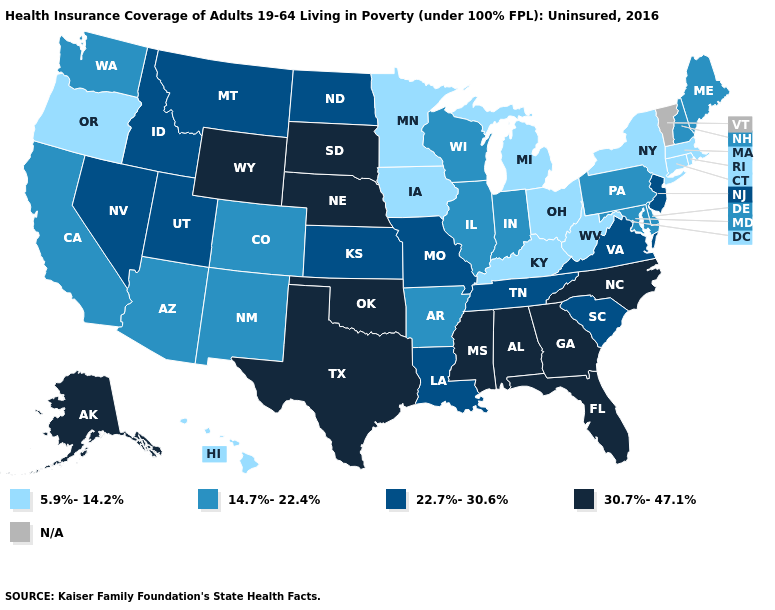What is the value of New Jersey?
Quick response, please. 22.7%-30.6%. Name the states that have a value in the range 22.7%-30.6%?
Short answer required. Idaho, Kansas, Louisiana, Missouri, Montana, Nevada, New Jersey, North Dakota, South Carolina, Tennessee, Utah, Virginia. What is the value of Kansas?
Short answer required. 22.7%-30.6%. Does Wisconsin have the lowest value in the MidWest?
Answer briefly. No. What is the value of South Dakota?
Concise answer only. 30.7%-47.1%. What is the value of Utah?
Give a very brief answer. 22.7%-30.6%. What is the value of Arkansas?
Quick response, please. 14.7%-22.4%. Name the states that have a value in the range 5.9%-14.2%?
Give a very brief answer. Connecticut, Hawaii, Iowa, Kentucky, Massachusetts, Michigan, Minnesota, New York, Ohio, Oregon, Rhode Island, West Virginia. What is the value of New Mexico?
Short answer required. 14.7%-22.4%. What is the highest value in the USA?
Short answer required. 30.7%-47.1%. Name the states that have a value in the range 22.7%-30.6%?
Short answer required. Idaho, Kansas, Louisiana, Missouri, Montana, Nevada, New Jersey, North Dakota, South Carolina, Tennessee, Utah, Virginia. What is the value of Washington?
Give a very brief answer. 14.7%-22.4%. Does the map have missing data?
Short answer required. Yes. Which states have the lowest value in the USA?
Write a very short answer. Connecticut, Hawaii, Iowa, Kentucky, Massachusetts, Michigan, Minnesota, New York, Ohio, Oregon, Rhode Island, West Virginia. 